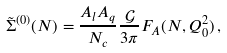Convert formula to latex. <formula><loc_0><loc_0><loc_500><loc_500>\tilde { \Sigma } ^ { ( 0 ) } ( N ) = \frac { A _ { l } A _ { q } } { N _ { c } } \frac { \mathcal { G } } { 3 \pi } F _ { A } ( N , Q _ { 0 } ^ { 2 } ) \, ,</formula> 